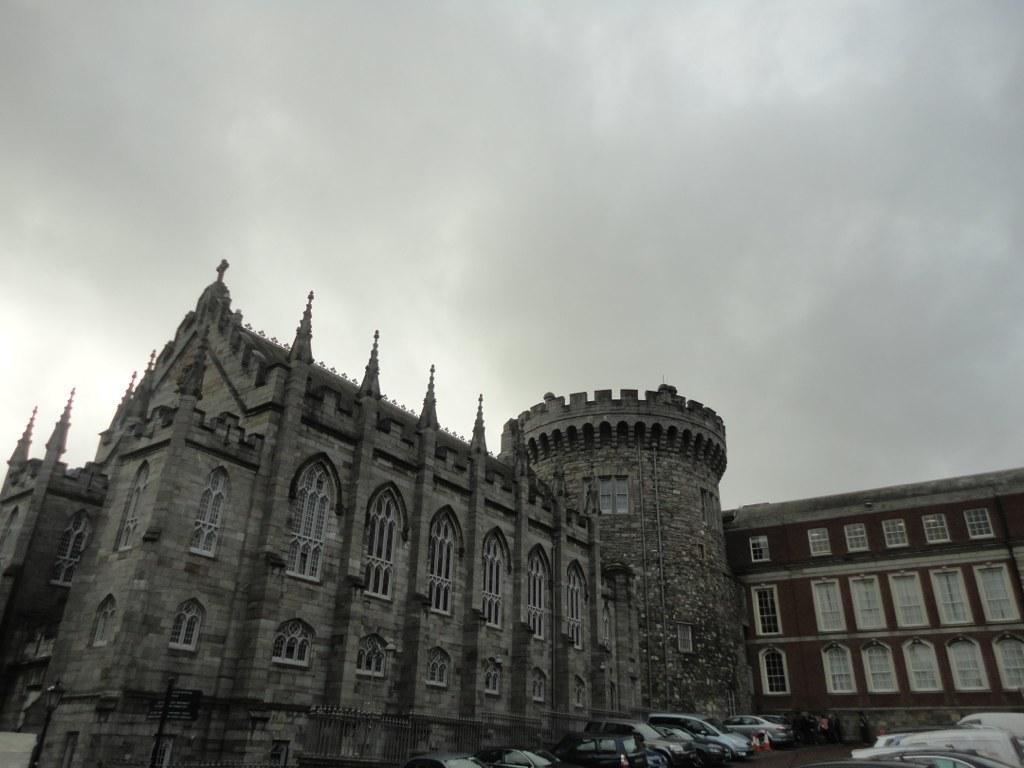In one or two sentences, can you explain what this image depicts? In this picture we can see a building, there are some windows here, we can see some cars parked here, there is the sky at the top of the picture. 